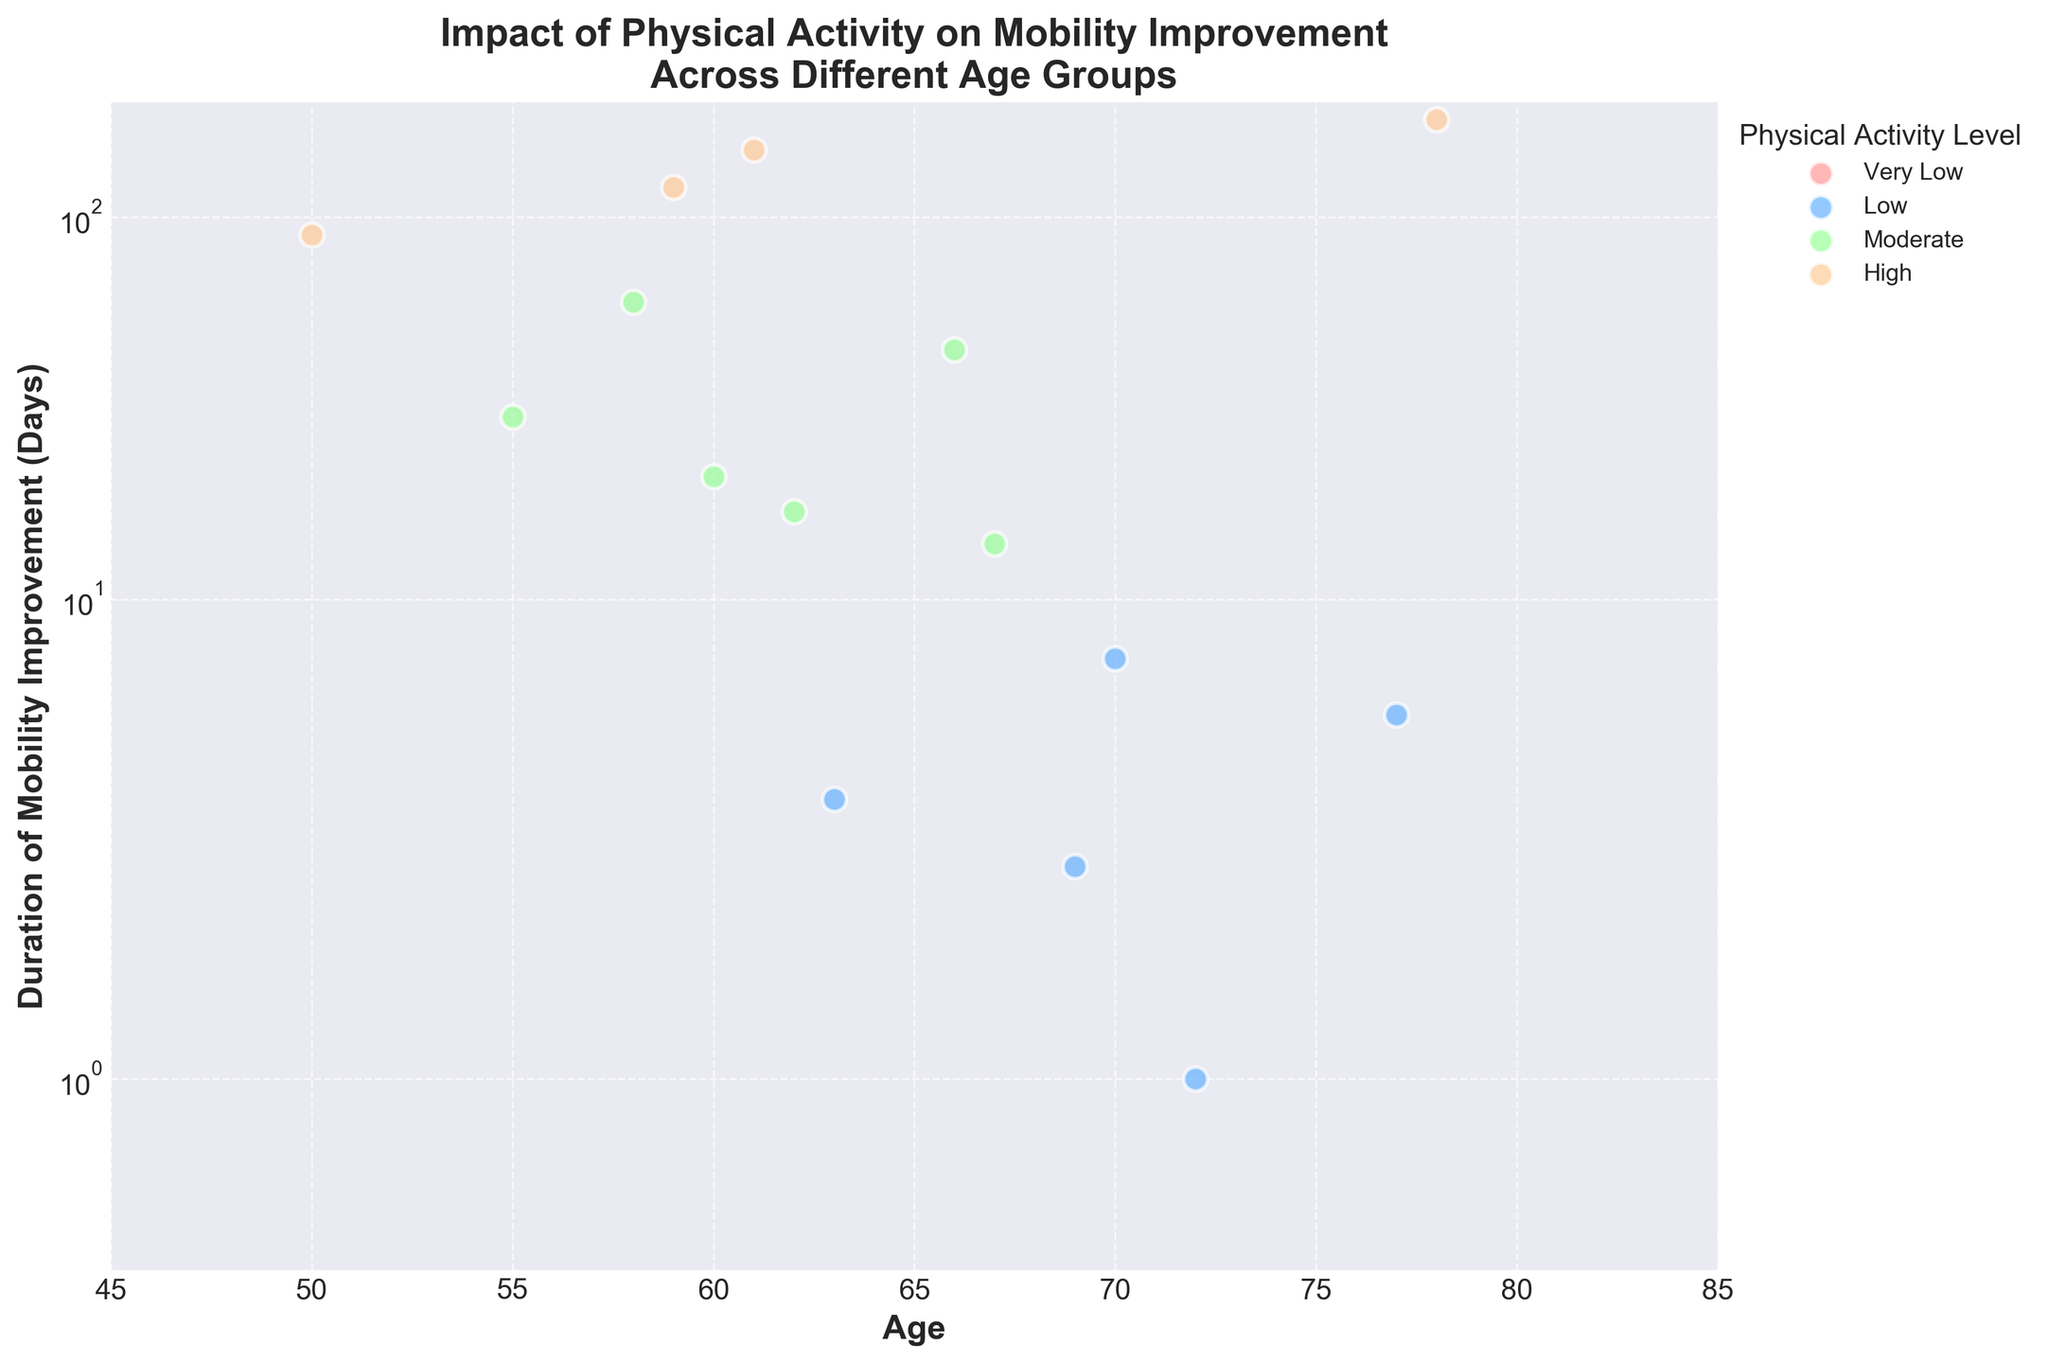What is the title of the plot? The title is written at the top of the plot and provides an overview of what the plot is about.
Answer: Impact of Physical Activity on Mobility Improvement Across Different Age Groups What is the age range shown on the x-axis? The x-axis range is depicted at the bottom of the plot.
Answer: 45 to 85 How is the y-axis scaled, and what range does it cover? The y-axis is scaled logarithmically, which is indicated by the term 'symlog' near the y-axis. The range is given in the plot from around 0.1 to 200 days.
Answer: Logarithmic, 0.1 to 200 How many categories of physical activity levels are plotted, and what are their colors? The legend on the right of the plot lists the categories and their corresponding colors.
Answer: Four categories: Very Low (light red), Low (light blue), Moderate (light green), High (light orange) Which physical activity level shows no mobility improvement duration across all patients? By looking at the plotted data points, observe which category has points at zero improvement duration.
Answer: Very Low Which age group shows the highest duration of mobility improvement, and under what activity level? Locate the highest point on the y-axis and check its x-axis alignment and color corresponding to the legend.
Answer: Age 62, High Which gender has more patients in the 'High' activity level category? Use the colors of the points in the 'High' category and check the gender indicated in the dataset.
Answer: Female Is there any pattern in mobility improvement duration concerning age for a particular activity level? Examine the scatter plot for a specific activity level and see if the points show a trend (increasing, decreasing, or no pattern).
Answer: No obvious pattern What is the maximum duration of mobility improvement observed for patients with 'Diabetes'? Look for the maximum y-value among the points labeled with the 'Diabetes' condition.
Answer: 180 days 